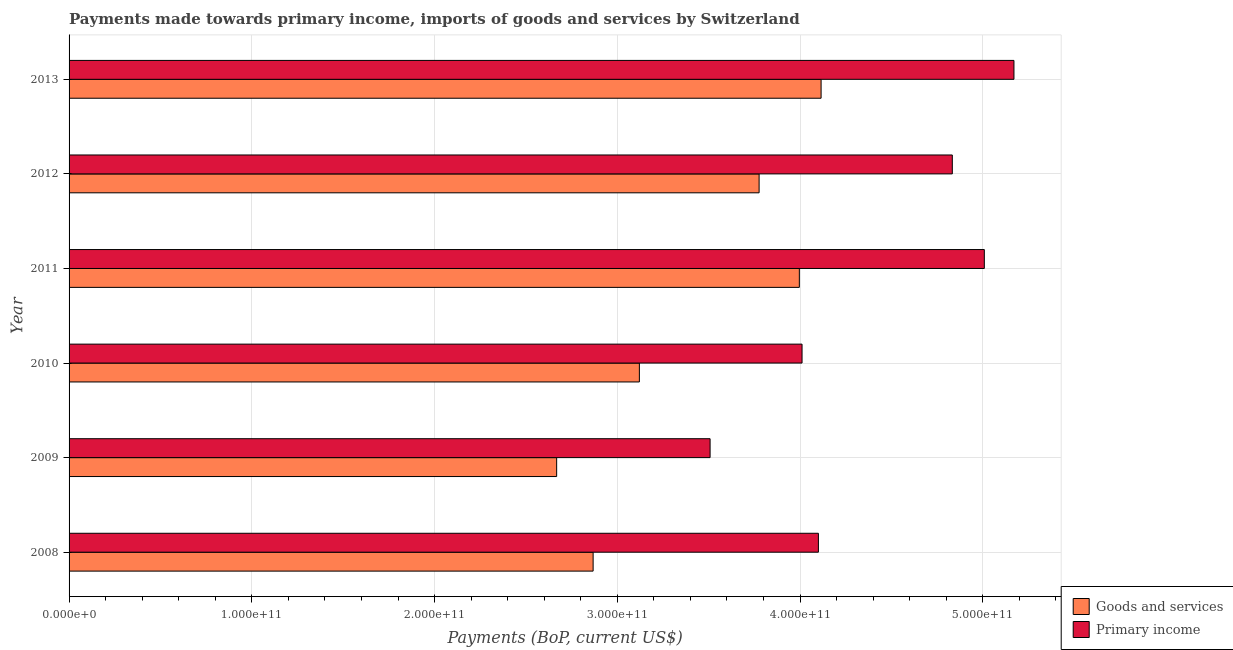How many groups of bars are there?
Give a very brief answer. 6. Are the number of bars on each tick of the Y-axis equal?
Your answer should be very brief. Yes. How many bars are there on the 2nd tick from the top?
Your answer should be compact. 2. In how many cases, is the number of bars for a given year not equal to the number of legend labels?
Provide a short and direct response. 0. What is the payments made towards primary income in 2010?
Ensure brevity in your answer.  4.01e+11. Across all years, what is the maximum payments made towards primary income?
Your answer should be very brief. 5.17e+11. Across all years, what is the minimum payments made towards goods and services?
Your answer should be compact. 2.67e+11. In which year was the payments made towards primary income maximum?
Give a very brief answer. 2013. In which year was the payments made towards primary income minimum?
Your answer should be compact. 2009. What is the total payments made towards primary income in the graph?
Your response must be concise. 2.66e+12. What is the difference between the payments made towards goods and services in 2011 and that in 2012?
Ensure brevity in your answer.  2.20e+1. What is the difference between the payments made towards primary income in 2010 and the payments made towards goods and services in 2013?
Ensure brevity in your answer.  -1.04e+1. What is the average payments made towards goods and services per year?
Provide a short and direct response. 3.42e+11. In the year 2010, what is the difference between the payments made towards goods and services and payments made towards primary income?
Make the answer very short. -8.90e+1. What is the ratio of the payments made towards primary income in 2009 to that in 2011?
Keep it short and to the point. 0.7. Is the payments made towards goods and services in 2009 less than that in 2013?
Provide a succinct answer. Yes. Is the difference between the payments made towards primary income in 2010 and 2011 greater than the difference between the payments made towards goods and services in 2010 and 2011?
Make the answer very short. No. What is the difference between the highest and the second highest payments made towards primary income?
Ensure brevity in your answer.  1.62e+1. What is the difference between the highest and the lowest payments made towards goods and services?
Offer a very short reply. 1.45e+11. Is the sum of the payments made towards goods and services in 2009 and 2010 greater than the maximum payments made towards primary income across all years?
Your response must be concise. Yes. What does the 1st bar from the top in 2009 represents?
Your answer should be very brief. Primary income. What does the 2nd bar from the bottom in 2010 represents?
Offer a very short reply. Primary income. How many years are there in the graph?
Provide a succinct answer. 6. What is the difference between two consecutive major ticks on the X-axis?
Provide a succinct answer. 1.00e+11. Does the graph contain any zero values?
Ensure brevity in your answer.  No. Where does the legend appear in the graph?
Keep it short and to the point. Bottom right. What is the title of the graph?
Your answer should be very brief. Payments made towards primary income, imports of goods and services by Switzerland. What is the label or title of the X-axis?
Provide a succinct answer. Payments (BoP, current US$). What is the label or title of the Y-axis?
Ensure brevity in your answer.  Year. What is the Payments (BoP, current US$) in Goods and services in 2008?
Your response must be concise. 2.87e+11. What is the Payments (BoP, current US$) of Primary income in 2008?
Offer a terse response. 4.10e+11. What is the Payments (BoP, current US$) of Goods and services in 2009?
Ensure brevity in your answer.  2.67e+11. What is the Payments (BoP, current US$) of Primary income in 2009?
Give a very brief answer. 3.51e+11. What is the Payments (BoP, current US$) of Goods and services in 2010?
Provide a short and direct response. 3.12e+11. What is the Payments (BoP, current US$) of Primary income in 2010?
Make the answer very short. 4.01e+11. What is the Payments (BoP, current US$) of Goods and services in 2011?
Make the answer very short. 4.00e+11. What is the Payments (BoP, current US$) of Primary income in 2011?
Your response must be concise. 5.01e+11. What is the Payments (BoP, current US$) in Goods and services in 2012?
Keep it short and to the point. 3.78e+11. What is the Payments (BoP, current US$) of Primary income in 2012?
Keep it short and to the point. 4.83e+11. What is the Payments (BoP, current US$) in Goods and services in 2013?
Keep it short and to the point. 4.11e+11. What is the Payments (BoP, current US$) of Primary income in 2013?
Offer a very short reply. 5.17e+11. Across all years, what is the maximum Payments (BoP, current US$) of Goods and services?
Offer a very short reply. 4.11e+11. Across all years, what is the maximum Payments (BoP, current US$) of Primary income?
Your answer should be compact. 5.17e+11. Across all years, what is the minimum Payments (BoP, current US$) in Goods and services?
Your answer should be very brief. 2.67e+11. Across all years, what is the minimum Payments (BoP, current US$) of Primary income?
Your answer should be compact. 3.51e+11. What is the total Payments (BoP, current US$) of Goods and services in the graph?
Ensure brevity in your answer.  2.05e+12. What is the total Payments (BoP, current US$) of Primary income in the graph?
Provide a succinct answer. 2.66e+12. What is the difference between the Payments (BoP, current US$) in Goods and services in 2008 and that in 2009?
Offer a terse response. 2.00e+1. What is the difference between the Payments (BoP, current US$) of Primary income in 2008 and that in 2009?
Give a very brief answer. 5.93e+1. What is the difference between the Payments (BoP, current US$) in Goods and services in 2008 and that in 2010?
Ensure brevity in your answer.  -2.53e+1. What is the difference between the Payments (BoP, current US$) of Primary income in 2008 and that in 2010?
Keep it short and to the point. 8.95e+09. What is the difference between the Payments (BoP, current US$) of Goods and services in 2008 and that in 2011?
Provide a short and direct response. -1.13e+11. What is the difference between the Payments (BoP, current US$) of Primary income in 2008 and that in 2011?
Give a very brief answer. -9.08e+1. What is the difference between the Payments (BoP, current US$) in Goods and services in 2008 and that in 2012?
Offer a very short reply. -9.08e+1. What is the difference between the Payments (BoP, current US$) of Primary income in 2008 and that in 2012?
Give a very brief answer. -7.33e+1. What is the difference between the Payments (BoP, current US$) in Goods and services in 2008 and that in 2013?
Make the answer very short. -1.25e+11. What is the difference between the Payments (BoP, current US$) in Primary income in 2008 and that in 2013?
Offer a terse response. -1.07e+11. What is the difference between the Payments (BoP, current US$) in Goods and services in 2009 and that in 2010?
Provide a short and direct response. -4.53e+1. What is the difference between the Payments (BoP, current US$) in Primary income in 2009 and that in 2010?
Provide a succinct answer. -5.03e+1. What is the difference between the Payments (BoP, current US$) in Goods and services in 2009 and that in 2011?
Make the answer very short. -1.33e+11. What is the difference between the Payments (BoP, current US$) in Primary income in 2009 and that in 2011?
Make the answer very short. -1.50e+11. What is the difference between the Payments (BoP, current US$) in Goods and services in 2009 and that in 2012?
Provide a short and direct response. -1.11e+11. What is the difference between the Payments (BoP, current US$) of Primary income in 2009 and that in 2012?
Keep it short and to the point. -1.33e+11. What is the difference between the Payments (BoP, current US$) of Goods and services in 2009 and that in 2013?
Your response must be concise. -1.45e+11. What is the difference between the Payments (BoP, current US$) in Primary income in 2009 and that in 2013?
Provide a short and direct response. -1.66e+11. What is the difference between the Payments (BoP, current US$) in Goods and services in 2010 and that in 2011?
Give a very brief answer. -8.75e+1. What is the difference between the Payments (BoP, current US$) of Primary income in 2010 and that in 2011?
Offer a very short reply. -9.97e+1. What is the difference between the Payments (BoP, current US$) of Goods and services in 2010 and that in 2012?
Provide a short and direct response. -6.55e+1. What is the difference between the Payments (BoP, current US$) in Primary income in 2010 and that in 2012?
Offer a terse response. -8.22e+1. What is the difference between the Payments (BoP, current US$) of Goods and services in 2010 and that in 2013?
Provide a succinct answer. -9.94e+1. What is the difference between the Payments (BoP, current US$) in Primary income in 2010 and that in 2013?
Offer a terse response. -1.16e+11. What is the difference between the Payments (BoP, current US$) in Goods and services in 2011 and that in 2012?
Offer a very short reply. 2.20e+1. What is the difference between the Payments (BoP, current US$) in Primary income in 2011 and that in 2012?
Offer a very short reply. 1.75e+1. What is the difference between the Payments (BoP, current US$) in Goods and services in 2011 and that in 2013?
Give a very brief answer. -1.19e+1. What is the difference between the Payments (BoP, current US$) of Primary income in 2011 and that in 2013?
Your answer should be compact. -1.62e+1. What is the difference between the Payments (BoP, current US$) of Goods and services in 2012 and that in 2013?
Provide a short and direct response. -3.39e+1. What is the difference between the Payments (BoP, current US$) in Primary income in 2012 and that in 2013?
Ensure brevity in your answer.  -3.37e+1. What is the difference between the Payments (BoP, current US$) of Goods and services in 2008 and the Payments (BoP, current US$) of Primary income in 2009?
Provide a succinct answer. -6.40e+1. What is the difference between the Payments (BoP, current US$) in Goods and services in 2008 and the Payments (BoP, current US$) in Primary income in 2010?
Offer a very short reply. -1.14e+11. What is the difference between the Payments (BoP, current US$) of Goods and services in 2008 and the Payments (BoP, current US$) of Primary income in 2011?
Provide a short and direct response. -2.14e+11. What is the difference between the Payments (BoP, current US$) of Goods and services in 2008 and the Payments (BoP, current US$) of Primary income in 2012?
Offer a terse response. -1.97e+11. What is the difference between the Payments (BoP, current US$) of Goods and services in 2008 and the Payments (BoP, current US$) of Primary income in 2013?
Your answer should be very brief. -2.30e+11. What is the difference between the Payments (BoP, current US$) in Goods and services in 2009 and the Payments (BoP, current US$) in Primary income in 2010?
Your answer should be compact. -1.34e+11. What is the difference between the Payments (BoP, current US$) of Goods and services in 2009 and the Payments (BoP, current US$) of Primary income in 2011?
Your answer should be compact. -2.34e+11. What is the difference between the Payments (BoP, current US$) in Goods and services in 2009 and the Payments (BoP, current US$) in Primary income in 2012?
Provide a short and direct response. -2.16e+11. What is the difference between the Payments (BoP, current US$) in Goods and services in 2009 and the Payments (BoP, current US$) in Primary income in 2013?
Provide a short and direct response. -2.50e+11. What is the difference between the Payments (BoP, current US$) of Goods and services in 2010 and the Payments (BoP, current US$) of Primary income in 2011?
Offer a terse response. -1.89e+11. What is the difference between the Payments (BoP, current US$) of Goods and services in 2010 and the Payments (BoP, current US$) of Primary income in 2012?
Give a very brief answer. -1.71e+11. What is the difference between the Payments (BoP, current US$) of Goods and services in 2010 and the Payments (BoP, current US$) of Primary income in 2013?
Offer a very short reply. -2.05e+11. What is the difference between the Payments (BoP, current US$) in Goods and services in 2011 and the Payments (BoP, current US$) in Primary income in 2012?
Make the answer very short. -8.37e+1. What is the difference between the Payments (BoP, current US$) in Goods and services in 2011 and the Payments (BoP, current US$) in Primary income in 2013?
Your answer should be compact. -1.17e+11. What is the difference between the Payments (BoP, current US$) in Goods and services in 2012 and the Payments (BoP, current US$) in Primary income in 2013?
Your answer should be very brief. -1.39e+11. What is the average Payments (BoP, current US$) of Goods and services per year?
Provide a succinct answer. 3.42e+11. What is the average Payments (BoP, current US$) of Primary income per year?
Give a very brief answer. 4.44e+11. In the year 2008, what is the difference between the Payments (BoP, current US$) of Goods and services and Payments (BoP, current US$) of Primary income?
Ensure brevity in your answer.  -1.23e+11. In the year 2009, what is the difference between the Payments (BoP, current US$) in Goods and services and Payments (BoP, current US$) in Primary income?
Offer a very short reply. -8.40e+1. In the year 2010, what is the difference between the Payments (BoP, current US$) in Goods and services and Payments (BoP, current US$) in Primary income?
Provide a short and direct response. -8.90e+1. In the year 2011, what is the difference between the Payments (BoP, current US$) in Goods and services and Payments (BoP, current US$) in Primary income?
Your response must be concise. -1.01e+11. In the year 2012, what is the difference between the Payments (BoP, current US$) of Goods and services and Payments (BoP, current US$) of Primary income?
Offer a terse response. -1.06e+11. In the year 2013, what is the difference between the Payments (BoP, current US$) in Goods and services and Payments (BoP, current US$) in Primary income?
Give a very brief answer. -1.06e+11. What is the ratio of the Payments (BoP, current US$) in Goods and services in 2008 to that in 2009?
Offer a terse response. 1.07. What is the ratio of the Payments (BoP, current US$) in Primary income in 2008 to that in 2009?
Provide a short and direct response. 1.17. What is the ratio of the Payments (BoP, current US$) in Goods and services in 2008 to that in 2010?
Make the answer very short. 0.92. What is the ratio of the Payments (BoP, current US$) in Primary income in 2008 to that in 2010?
Your response must be concise. 1.02. What is the ratio of the Payments (BoP, current US$) in Goods and services in 2008 to that in 2011?
Provide a short and direct response. 0.72. What is the ratio of the Payments (BoP, current US$) of Primary income in 2008 to that in 2011?
Make the answer very short. 0.82. What is the ratio of the Payments (BoP, current US$) of Goods and services in 2008 to that in 2012?
Ensure brevity in your answer.  0.76. What is the ratio of the Payments (BoP, current US$) in Primary income in 2008 to that in 2012?
Your response must be concise. 0.85. What is the ratio of the Payments (BoP, current US$) in Goods and services in 2008 to that in 2013?
Provide a succinct answer. 0.7. What is the ratio of the Payments (BoP, current US$) in Primary income in 2008 to that in 2013?
Keep it short and to the point. 0.79. What is the ratio of the Payments (BoP, current US$) in Goods and services in 2009 to that in 2010?
Make the answer very short. 0.85. What is the ratio of the Payments (BoP, current US$) in Primary income in 2009 to that in 2010?
Keep it short and to the point. 0.87. What is the ratio of the Payments (BoP, current US$) of Goods and services in 2009 to that in 2011?
Provide a short and direct response. 0.67. What is the ratio of the Payments (BoP, current US$) in Primary income in 2009 to that in 2011?
Your answer should be very brief. 0.7. What is the ratio of the Payments (BoP, current US$) of Goods and services in 2009 to that in 2012?
Give a very brief answer. 0.71. What is the ratio of the Payments (BoP, current US$) of Primary income in 2009 to that in 2012?
Offer a very short reply. 0.73. What is the ratio of the Payments (BoP, current US$) in Goods and services in 2009 to that in 2013?
Your answer should be very brief. 0.65. What is the ratio of the Payments (BoP, current US$) of Primary income in 2009 to that in 2013?
Your response must be concise. 0.68. What is the ratio of the Payments (BoP, current US$) in Goods and services in 2010 to that in 2011?
Ensure brevity in your answer.  0.78. What is the ratio of the Payments (BoP, current US$) of Primary income in 2010 to that in 2011?
Provide a short and direct response. 0.8. What is the ratio of the Payments (BoP, current US$) of Goods and services in 2010 to that in 2012?
Your response must be concise. 0.83. What is the ratio of the Payments (BoP, current US$) in Primary income in 2010 to that in 2012?
Your answer should be very brief. 0.83. What is the ratio of the Payments (BoP, current US$) in Goods and services in 2010 to that in 2013?
Keep it short and to the point. 0.76. What is the ratio of the Payments (BoP, current US$) in Primary income in 2010 to that in 2013?
Ensure brevity in your answer.  0.78. What is the ratio of the Payments (BoP, current US$) in Goods and services in 2011 to that in 2012?
Ensure brevity in your answer.  1.06. What is the ratio of the Payments (BoP, current US$) in Primary income in 2011 to that in 2012?
Your answer should be very brief. 1.04. What is the ratio of the Payments (BoP, current US$) in Goods and services in 2011 to that in 2013?
Your answer should be compact. 0.97. What is the ratio of the Payments (BoP, current US$) of Primary income in 2011 to that in 2013?
Provide a succinct answer. 0.97. What is the ratio of the Payments (BoP, current US$) in Goods and services in 2012 to that in 2013?
Your answer should be very brief. 0.92. What is the ratio of the Payments (BoP, current US$) of Primary income in 2012 to that in 2013?
Your answer should be very brief. 0.93. What is the difference between the highest and the second highest Payments (BoP, current US$) in Goods and services?
Provide a succinct answer. 1.19e+1. What is the difference between the highest and the second highest Payments (BoP, current US$) in Primary income?
Give a very brief answer. 1.62e+1. What is the difference between the highest and the lowest Payments (BoP, current US$) in Goods and services?
Keep it short and to the point. 1.45e+11. What is the difference between the highest and the lowest Payments (BoP, current US$) of Primary income?
Provide a short and direct response. 1.66e+11. 